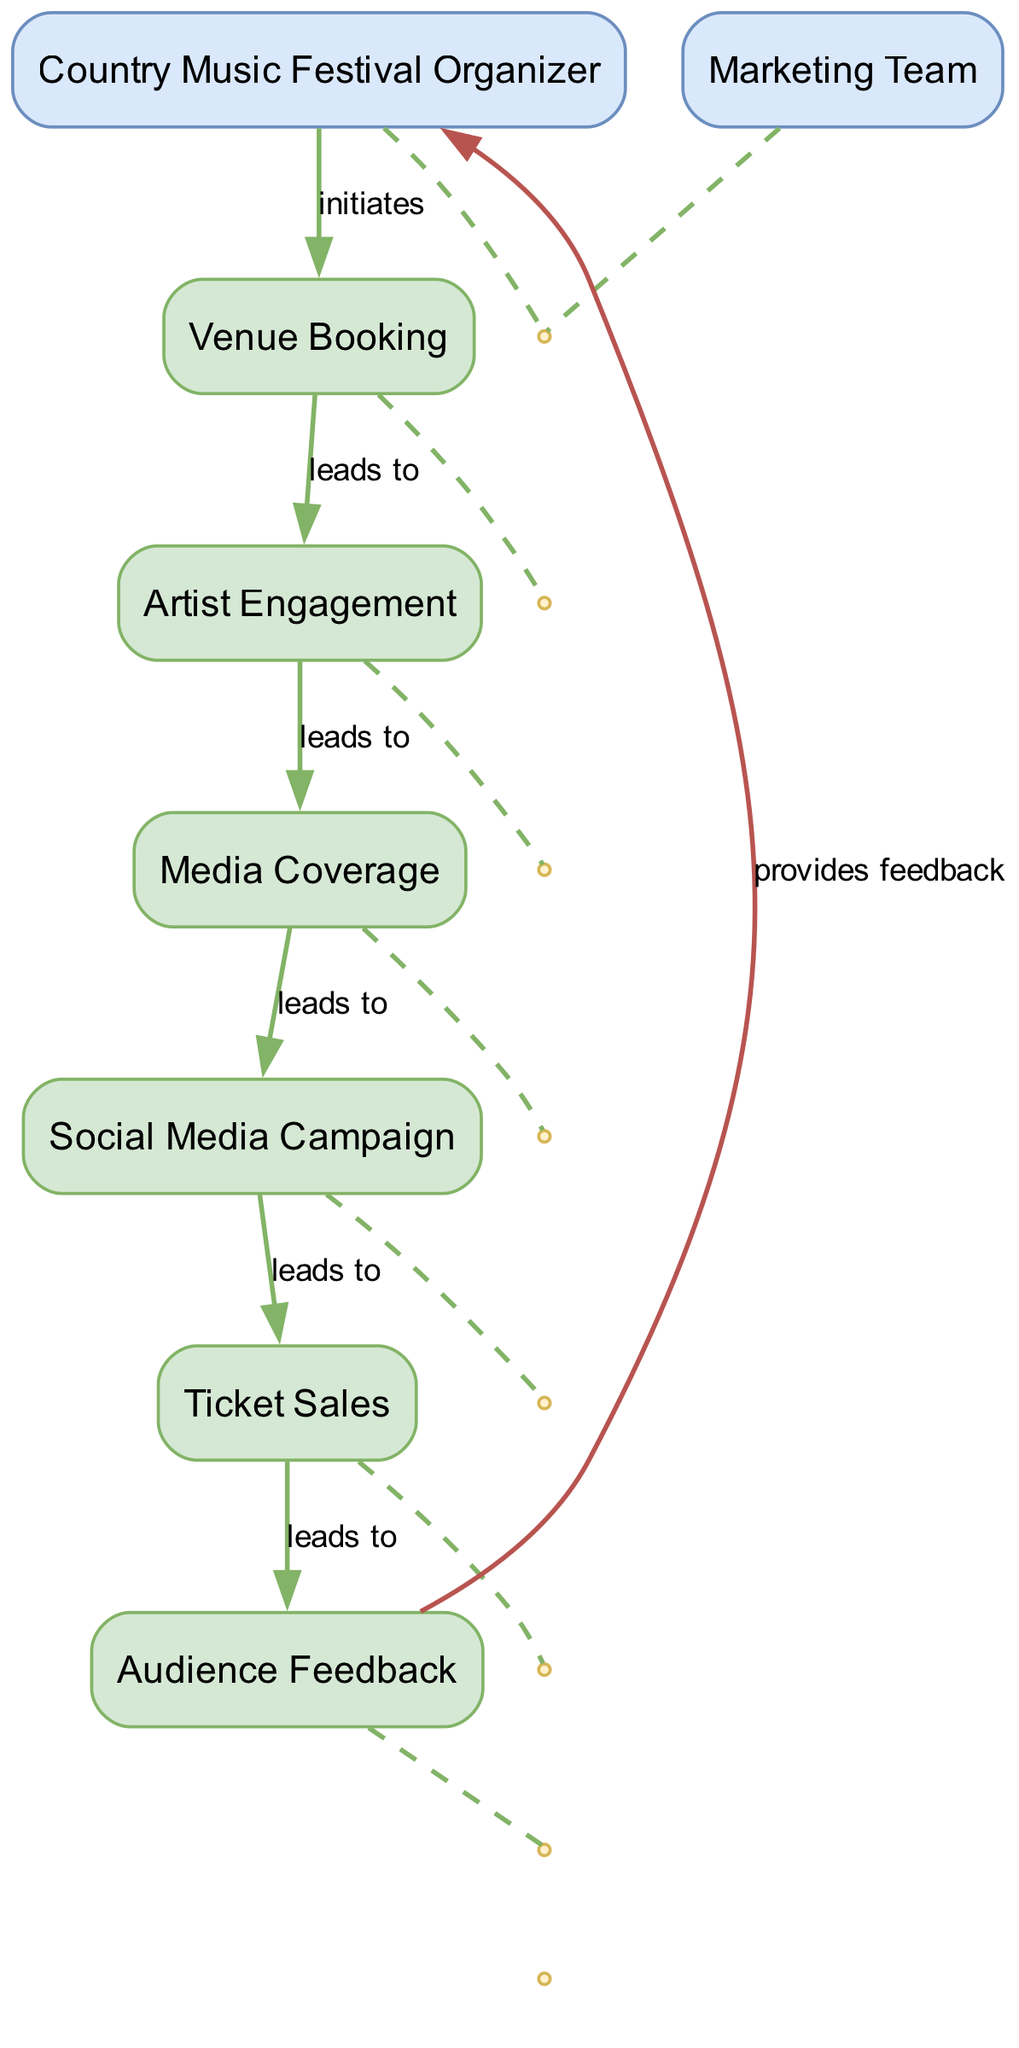What process initiates the festival organization? The Country Music Festival Organizer is the first actor in the diagram, and they initiate the planning of the festival. This is shown by the arrow leading from the organizer to the first process node, which is Venue Booking.
Answer: Venue Booking How many processes are involved in the sequence? The diagram includes eight processes listed from Venue Booking through to Audience Feedback. Counting these processes shows their sequence in organizing the festival.
Answer: Eight Which actor is responsible for promoting the festival? The Marketing Team is indicated in the diagram as the actor responsible for promoting the festival. This is depicted visually as a distinct entity that interacts with the promotional processes.
Answer: Marketing Team What process follows Artist Engagement? The sequence shows that after Artist Engagement, the next process is Marketing Team, which signifies that after engaging artists, the promotion phase begins.
Answer: Marketing Team What feedback is provided at the end of the process? The Audience Feedback process indicates that feedback is collected from festival attendees after the event. This is part of the final steps, leading back to the organizer role in the feedback loop.
Answer: Provides feedback Which process manages the sales for the festival? The diagram distinctly shows Ticket Sales as the process dedicated to managing all the sales of tickets for the festival. It is clearly labeled and sequenced appropriately in the flow.
Answer: Ticket Sales What is the relationship between Media Coverage and Social Media Campaign? Media Coverage is shown as occurring before the Social Media Campaign. The sequence indicates that coordinating media coverage leads to the execution of social media promotional activities.
Answer: Leads to What does the arrow labeled 'provides feedback' indicate? The arrow labeled 'provides feedback' suggests a loop back to the Country Music Festival Organizer from the Audience Feedback process, indicating that feedback from attendees is communicated back to the organizer for future improvements.
Answer: Provides feedback 